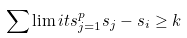<formula> <loc_0><loc_0><loc_500><loc_500>\sum \lim i t s _ { j = 1 } ^ { p } s _ { j } - s _ { i } \geq k</formula> 